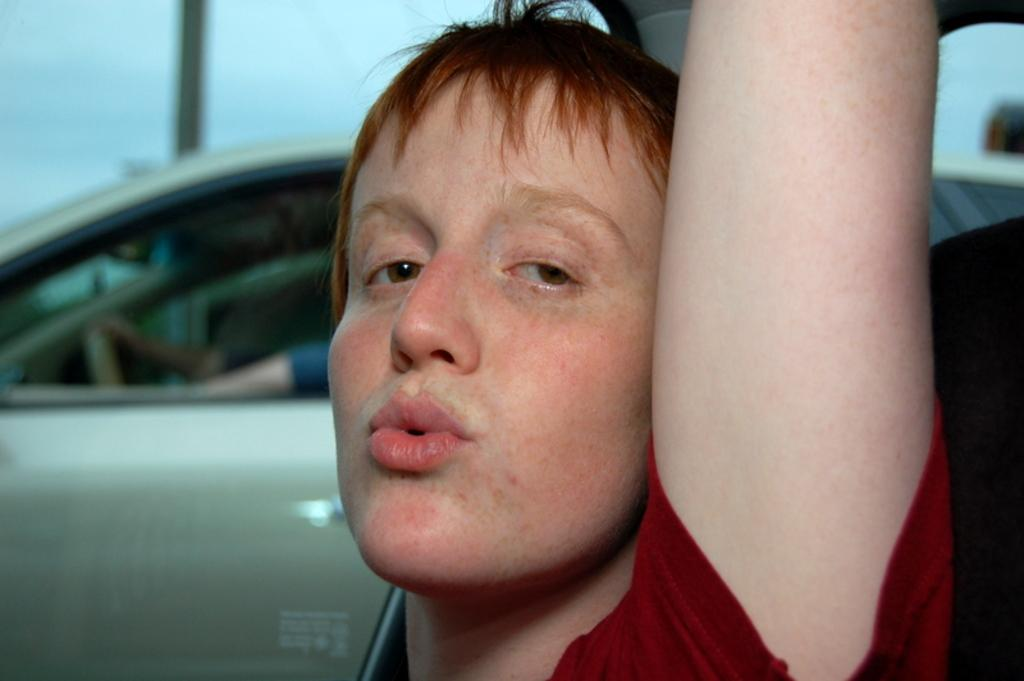Who or what is the main subject in the image? There is a person in the image. What can be seen in the background of the image? There is a vehicle in the background of the image. What is the person in the image doing? The hands of a person holding a steering wheel are visible in the image, suggesting that the person is driving the vehicle. What type of seat is the person sitting on in the image? The provided facts do not mention a seat, so it cannot be determined from the image. 